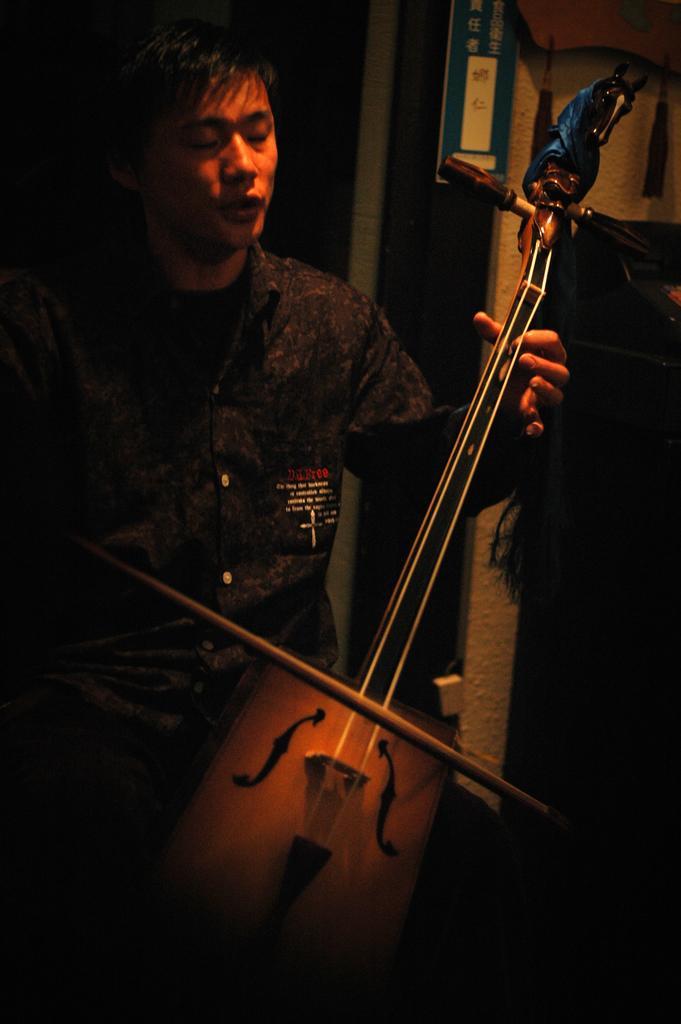Could you give a brief overview of what you see in this image? In this picture a guy is playing a violin , in the background there are posters , hangings. To the right side of the image there is a brown color wooden shelf. 